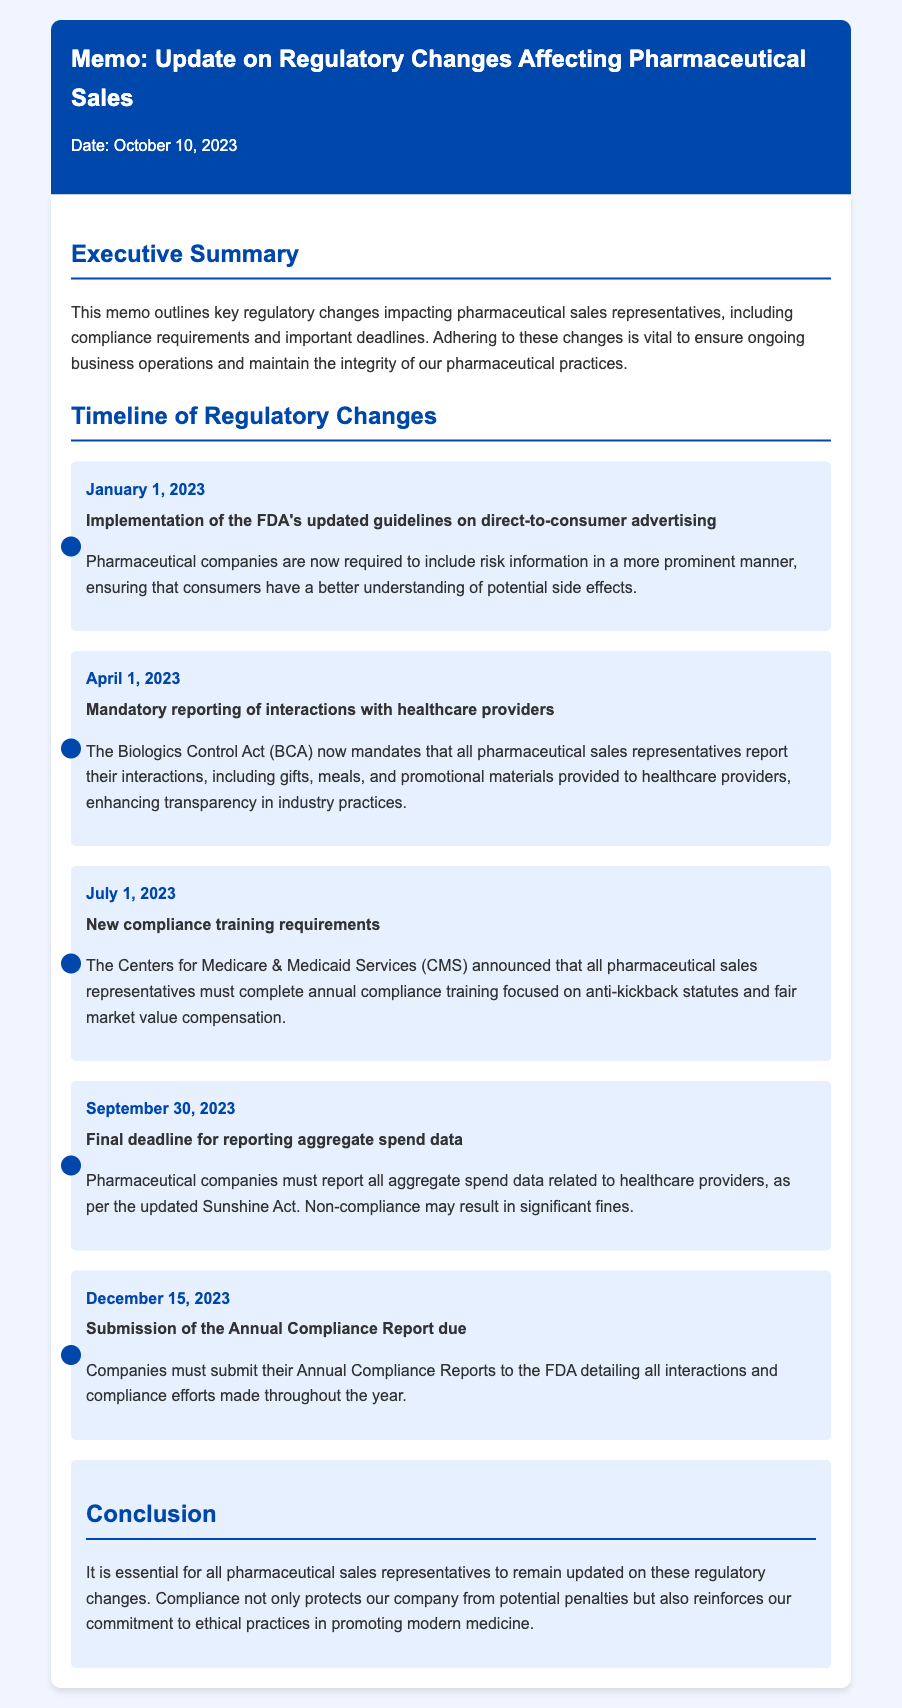What is the date of the memo? The memo was created on October 10, 2023, which is stated at the top of the document under the header section.
Answer: October 10, 2023 When did the FDA's updated guidelines on direct-to-consumer advertising become effective? The effective date for the FDA's updated guidelines is mentioned in the timeline section under the January 1, 2023 item.
Answer: January 1, 2023 What is the final deadline for reporting aggregate spend data? The deadline for reporting aggregate spend data is specified in the timeline under the September 30, 2023 item.
Answer: September 30, 2023 Which act mandates the reporting of interactions with healthcare providers? The document states that the Biologics Control Act (BCA) mandates the reporting of interactions in the April 1, 2023 timeline item.
Answer: Biologics Control Act (BCA) What must pharmaceutical sales representatives complete annually according to the new compliance training requirements? It is stated in the July 1, 2023 entry that they must complete training focused on anti-kickback statutes and fair market value compensation.
Answer: Compliance training What is the due date for the Annual Compliance Report submission? The submission date for the Annual Compliance Report is outlined for December 15, 2023 in the timeline.
Answer: December 15, 2023 What is emphasized as essential for pharmaceutical sales representatives in the conclusion? The conclusion emphasizes the importance of remaining updated on regulatory changes to protect the company and reinforce ethical practices.
Answer: Compliance What is the main purpose of the memo? The purpose of the memo is outlined in the Executive Summary and is to inform about key regulatory changes impacting pharmaceutical sales representatives.
Answer: Inform about regulatory changes 